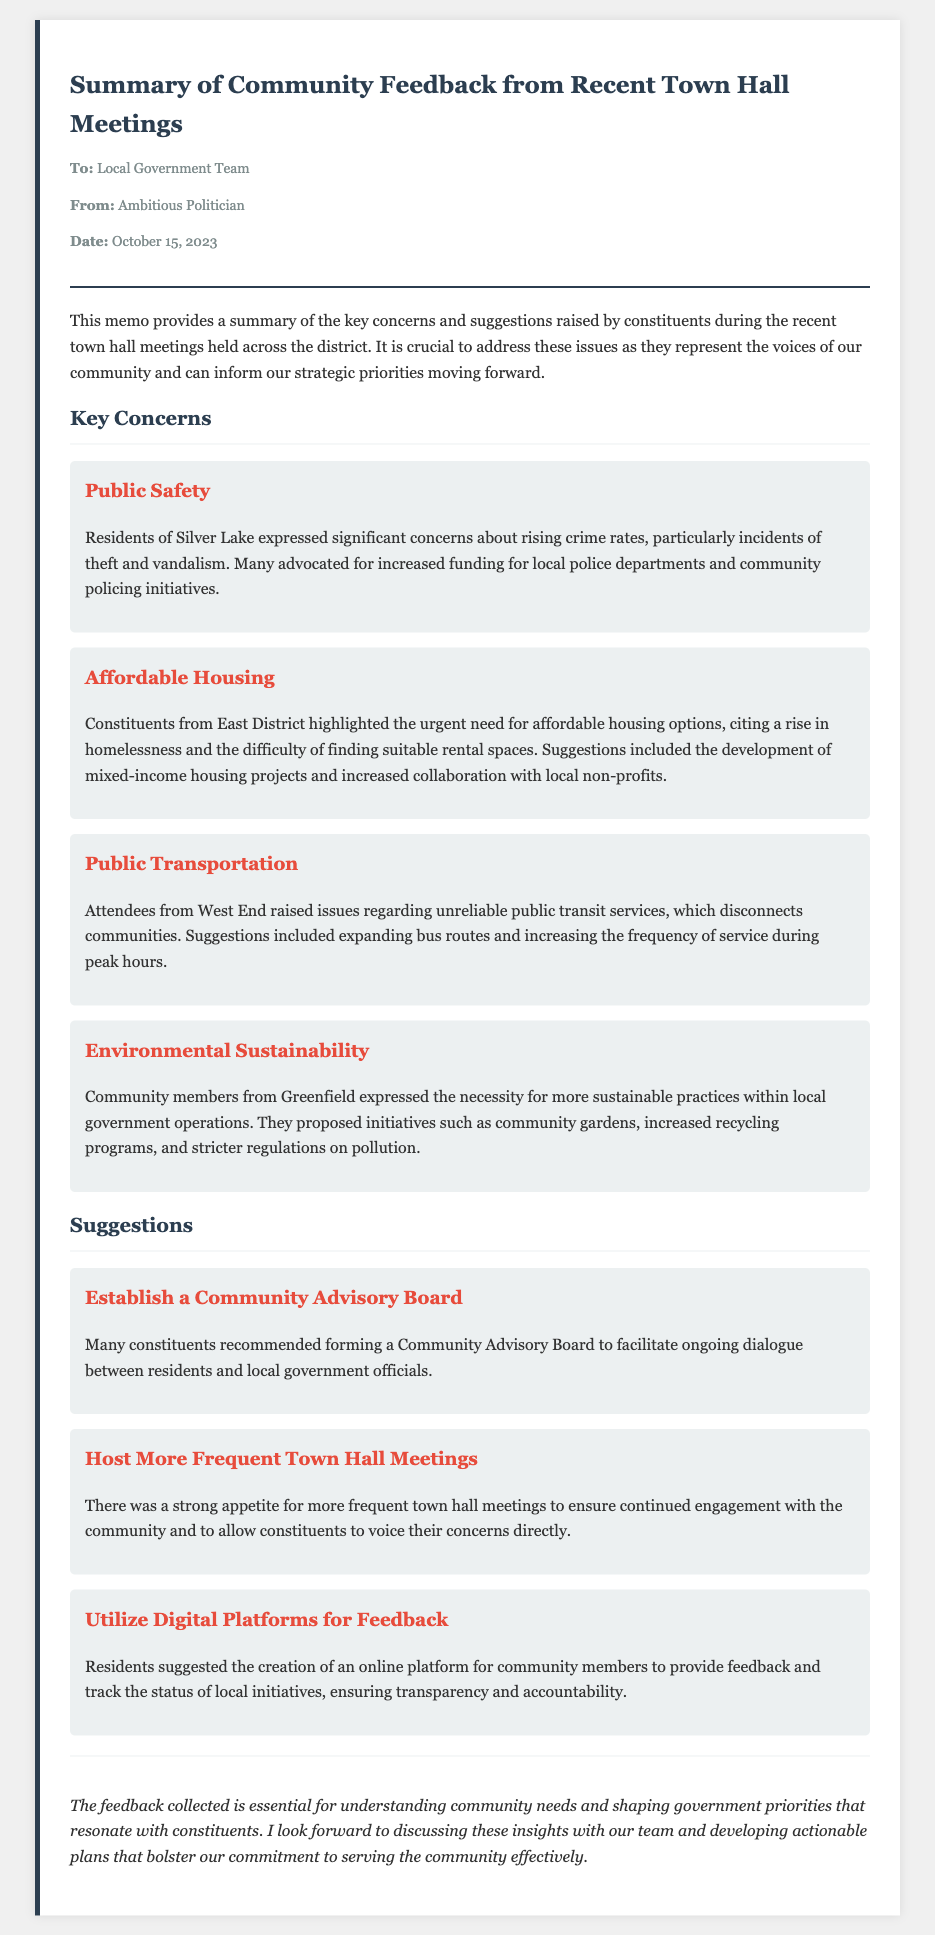What is the date of the memo? The date of the memo is stated in the header section as October 15, 2023.
Answer: October 15, 2023 Who expressed concerns about rising crime rates? Residents of Silver Lake expressed concerns about rising crime rates.
Answer: Silver Lake What is one suggestion made by constituents regarding transportation? Attendees from West End suggested expanding bus routes and increasing service frequency.
Answer: Expand bus routes What issue is highlighted as urgent by constituents from East District? The urgent issue highlighted is the need for affordable housing options.
Answer: Affordable housing What is one proposed initiative for environmental sustainability? Community members proposed initiatives such as community gardens.
Answer: Community gardens How many key concerns are listed in the memo? The memo lists four key concerns under the "Key Concerns" section.
Answer: Four What is a suggested method for increased community engagement? Many constituents recommended hosting more frequent town hall meetings.
Answer: More frequent town hall meetings What type of board was suggested to facilitate dialogue with the community? The suggestion was to establish a Community Advisory Board.
Answer: Community Advisory Board What is the tone of the conclusion in the memo? The tone of the conclusion is optimistic about future plans and community engagement.
Answer: Optimistic 